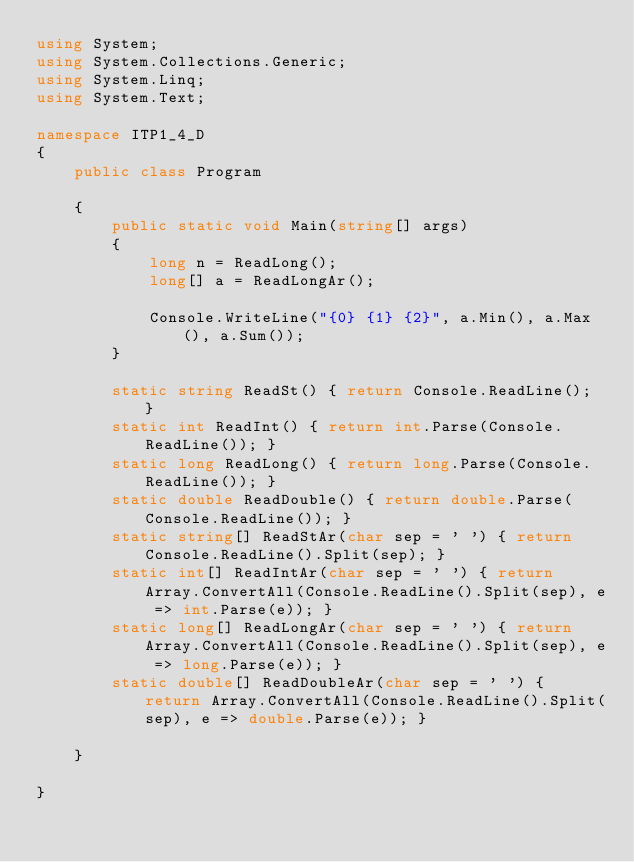<code> <loc_0><loc_0><loc_500><loc_500><_C#_>using System;
using System.Collections.Generic;
using System.Linq;
using System.Text;

namespace ITP1_4_D
{
    public class Program

    {
        public static void Main(string[] args)
        {
            long n = ReadLong();
            long[] a = ReadLongAr();

            Console.WriteLine("{0} {1} {2}", a.Min(), a.Max(), a.Sum());
        }

        static string ReadSt() { return Console.ReadLine(); }
        static int ReadInt() { return int.Parse(Console.ReadLine()); }
        static long ReadLong() { return long.Parse(Console.ReadLine()); }
        static double ReadDouble() { return double.Parse(Console.ReadLine()); }
        static string[] ReadStAr(char sep = ' ') { return Console.ReadLine().Split(sep); }
        static int[] ReadIntAr(char sep = ' ') { return Array.ConvertAll(Console.ReadLine().Split(sep), e => int.Parse(e)); }
        static long[] ReadLongAr(char sep = ' ') { return Array.ConvertAll(Console.ReadLine().Split(sep), e => long.Parse(e)); }
        static double[] ReadDoubleAr(char sep = ' ') { return Array.ConvertAll(Console.ReadLine().Split(sep), e => double.Parse(e)); }

    }

}

</code> 